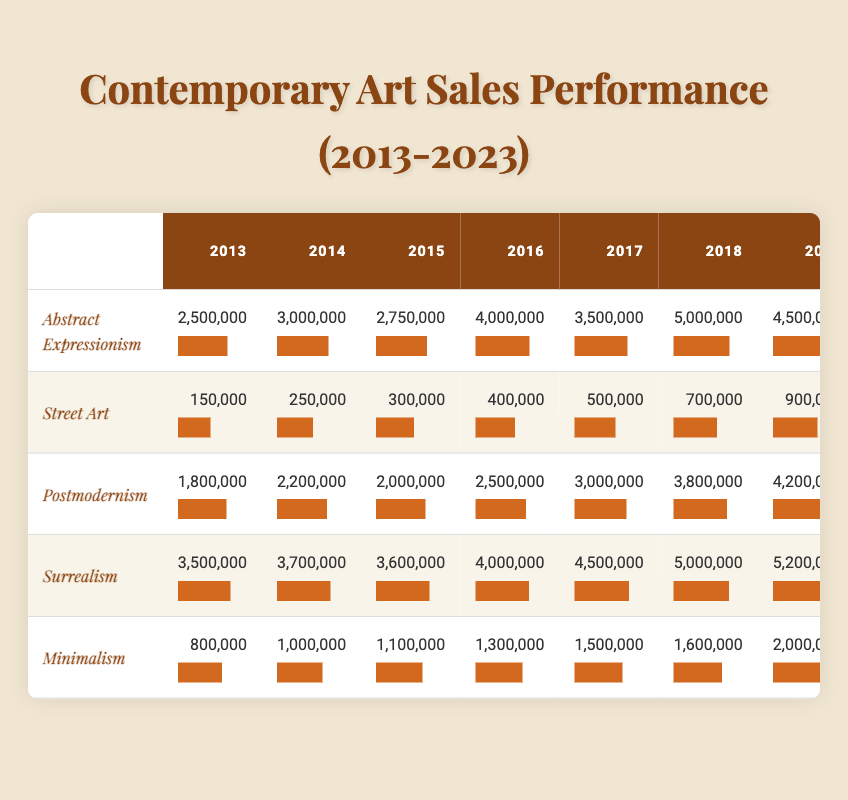What was the highest sales performance for Abstract Expressionism? The highest sales performance for Abstract Expressionism can be found in the year 2022, where the value is 8,000,000.
Answer: 8,000,000 In which year did Street Art sales first exceed 1,000,000? The years for Street Art sales can be examined from 2013 to 2023, and the first instance of sales exceeding 1,000,000 occurred in 2020, where sales were 1,100,000.
Answer: 2020 Which art movement had the least sales performance in 2013? Among the art movements listed for 2013, Street Art had the lowest sales performance at 150,000. This can be identified by comparing each value in that year.
Answer: 150,000 What is the average sales performance for Surrealism over the last decade? To find the average, sum all the sales performances from 2013 to 2023 for Surrealism, which are: 3,500,000 + 3,700,000 + 3,600,000 + 4,000,000 + 4,500,000 + 5,000,000 + 5,200,000 + 6,000,000 + 6,200,000 + 6,700,000 + 7,000,000 = 58,700,000. This is then divided by the number of years (11), resulting in an average of 5,354,545.45 which can be rounded to 5,354,545.
Answer: 5,354,545 Did Minimalism have a higher sales performance than Postmodernism in 2021? In 2021, Minimalism had sales of 2,500,000 while Postmodernism had sales of 5,500,000. Comparing these two values, Minimalism's performance was lower than Postmodernism's, thus the answer is no.
Answer: No What was the total sales performance for each of the art movements in 2019? By checking the sales for 2019 for each movement: Abstract Expressionism (4,500,000), Street Art (900,000), Postmodernism (4,200,000), Surrealism (5,200,000), and Minimalism (2,000,000). Adding these gives a total of 4,500,000 + 900,000 + 4,200,000 + 5,200,000 + 2,000,000 = 16,800,000.
Answer: 16,800,000 Which art movement showed the most consistent growth over the decade? By analyzing the growth patterns from year to year, Abstract Expressionism showed constant growth from 2013 to 2018 but had a small decline in 2023 compared to 2022. Surrealism was also quite steady, with only small fluctuations. However, the most consistent overall growth is noted in Abstract Expressionism despite its final dip after peak growth in 2022.
Answer: Abstract Expressionism What was the sales increase of Postmodernism from 2013 to 2023? The sales for Postmodernism in 2013 were 1,800,000 and in 2023 they were 6,400,000. To calculate the increase, subtract the 2013 value from the 2023 value: 6,400,000 - 1,800,000 = 4,600,000.
Answer: 4,600,000 